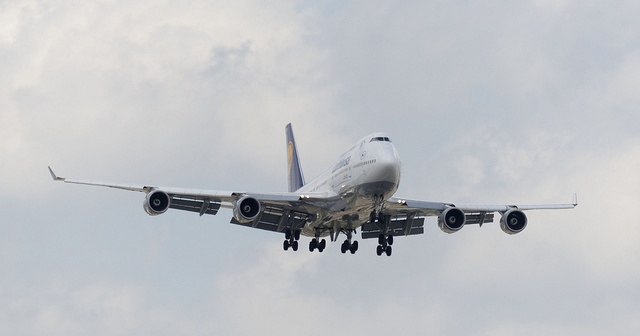Describe the objects in this image and their specific colors. I can see a airplane in lightgray, black, gray, and darkgray tones in this image. 